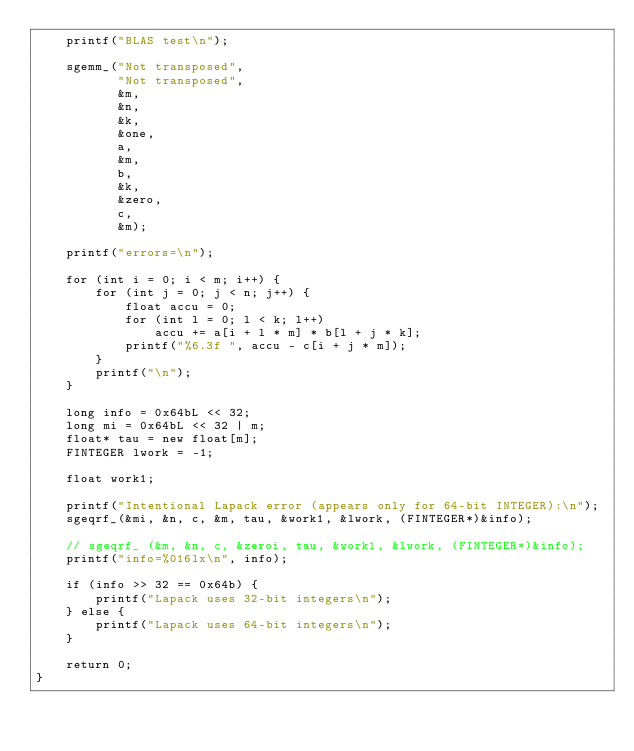Convert code to text. <code><loc_0><loc_0><loc_500><loc_500><_C++_>    printf("BLAS test\n");

    sgemm_("Not transposed",
           "Not transposed",
           &m,
           &n,
           &k,
           &one,
           a,
           &m,
           b,
           &k,
           &zero,
           c,
           &m);

    printf("errors=\n");

    for (int i = 0; i < m; i++) {
        for (int j = 0; j < n; j++) {
            float accu = 0;
            for (int l = 0; l < k; l++)
                accu += a[i + l * m] * b[l + j * k];
            printf("%6.3f ", accu - c[i + j * m]);
        }
        printf("\n");
    }

    long info = 0x64bL << 32;
    long mi = 0x64bL << 32 | m;
    float* tau = new float[m];
    FINTEGER lwork = -1;

    float work1;

    printf("Intentional Lapack error (appears only for 64-bit INTEGER):\n");
    sgeqrf_(&mi, &n, c, &m, tau, &work1, &lwork, (FINTEGER*)&info);

    // sgeqrf_ (&m, &n, c, &zeroi, tau, &work1, &lwork, (FINTEGER*)&info);
    printf("info=%016lx\n", info);

    if (info >> 32 == 0x64b) {
        printf("Lapack uses 32-bit integers\n");
    } else {
        printf("Lapack uses 64-bit integers\n");
    }

    return 0;
}
</code> 